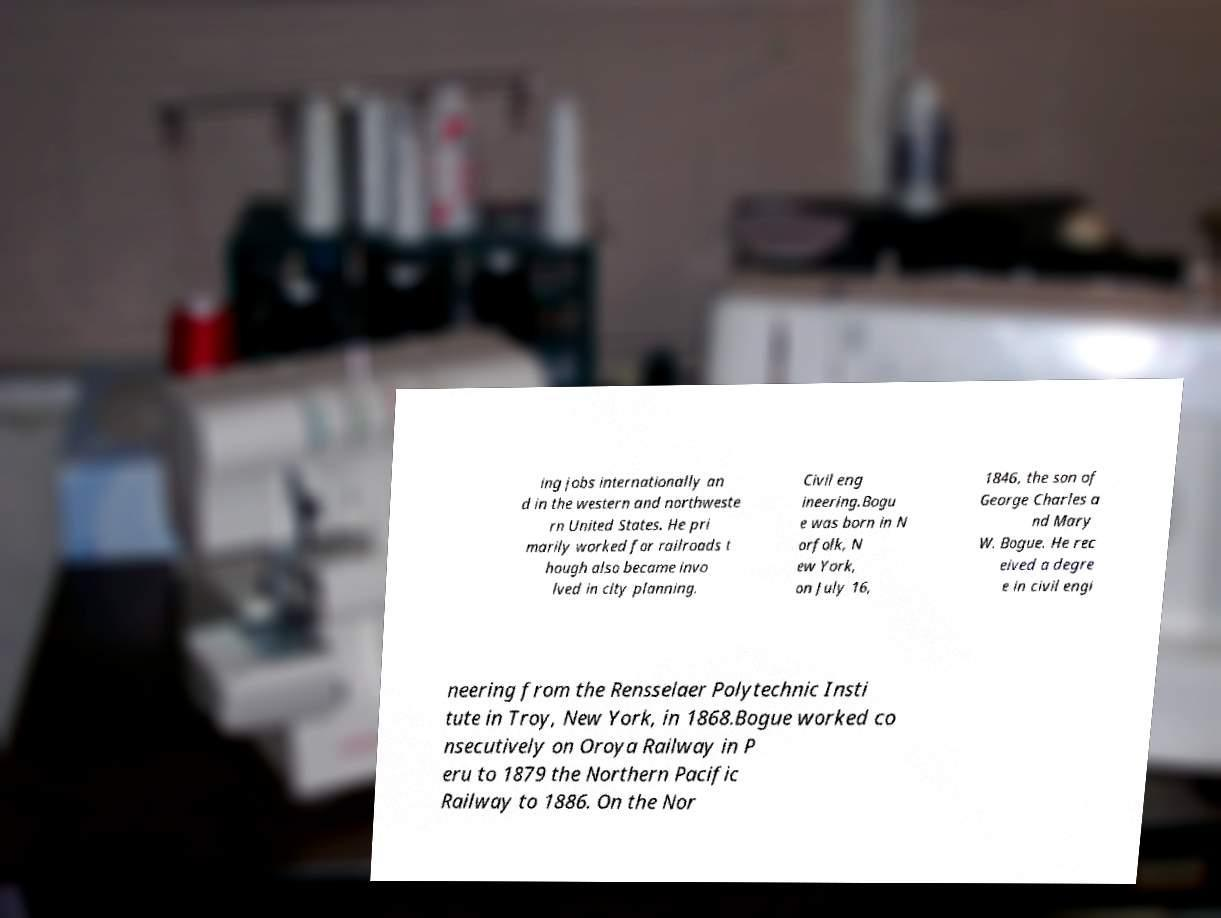Can you accurately transcribe the text from the provided image for me? ing jobs internationally an d in the western and northweste rn United States. He pri marily worked for railroads t hough also became invo lved in city planning. Civil eng ineering.Bogu e was born in N orfolk, N ew York, on July 16, 1846, the son of George Charles a nd Mary W. Bogue. He rec eived a degre e in civil engi neering from the Rensselaer Polytechnic Insti tute in Troy, New York, in 1868.Bogue worked co nsecutively on Oroya Railway in P eru to 1879 the Northern Pacific Railway to 1886. On the Nor 